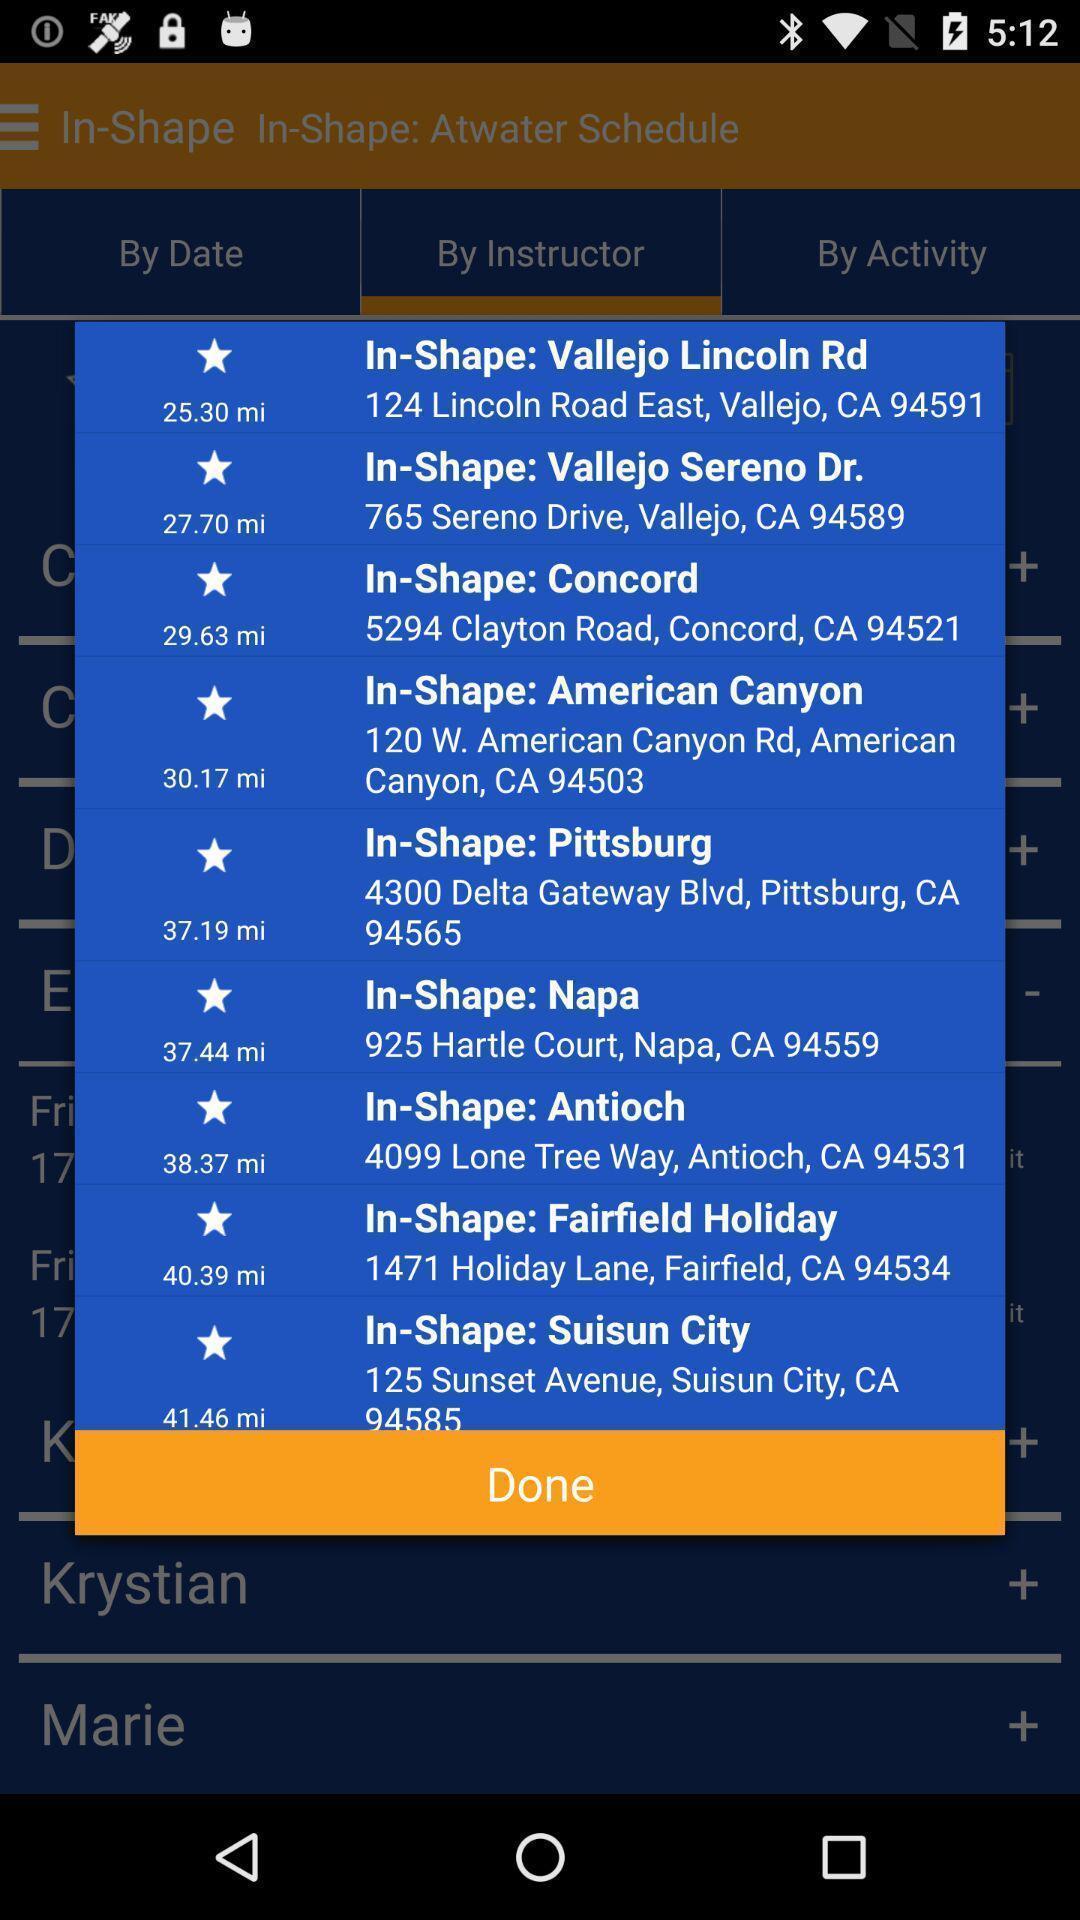Give me a narrative description of this picture. Pop-up showing the different locations. 